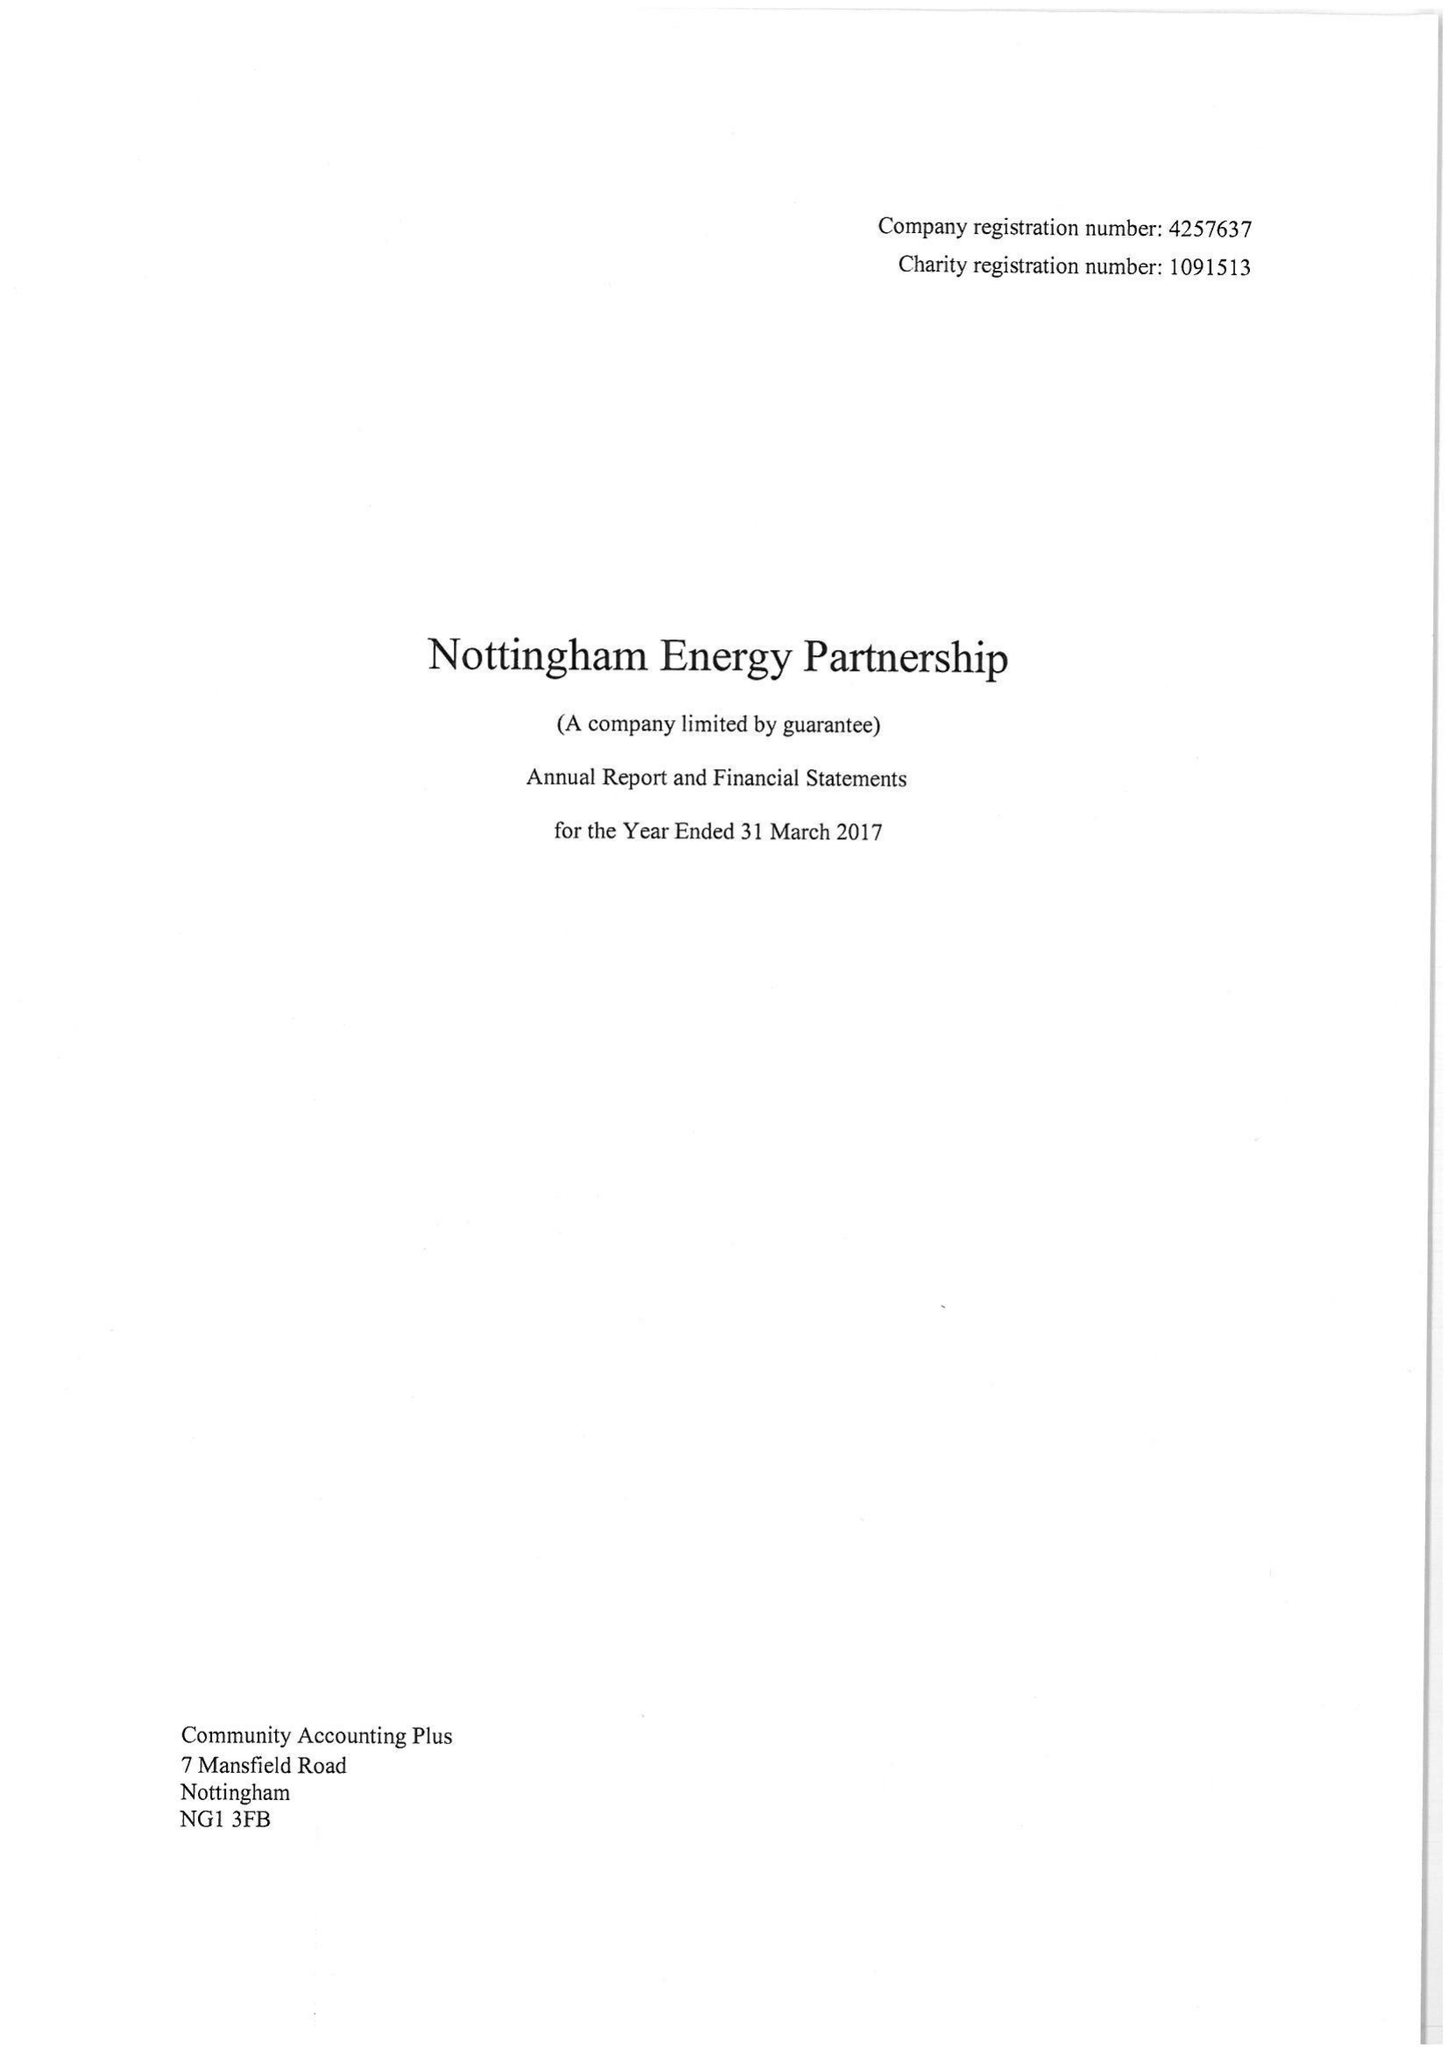What is the value for the charity_number?
Answer the question using a single word or phrase. 1091513 